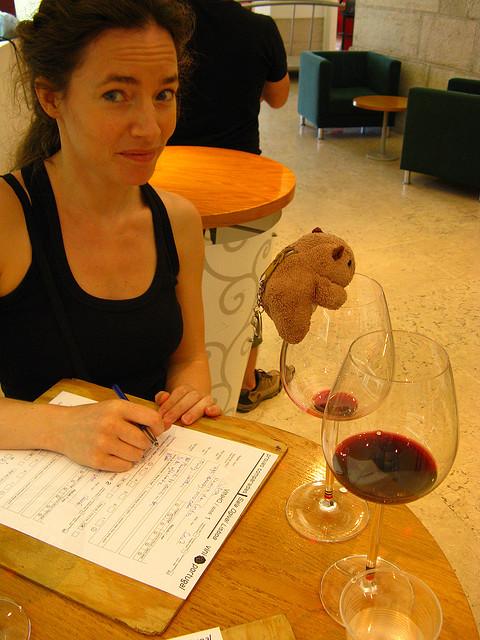What is on a wine glass?
Write a very short answer. Stuffed animal. What color is the woman's top?
Concise answer only. Black. What type of glass is on the table?
Quick response, please. Wine. What occasion is this?
Answer briefly. Birthday. Is she about to eat?
Quick response, please. No. 